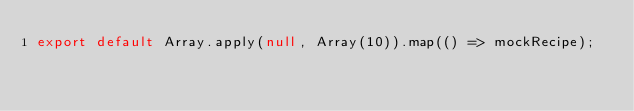<code> <loc_0><loc_0><loc_500><loc_500><_JavaScript_>export default Array.apply(null, Array(10)).map(() => mockRecipe);
</code> 